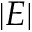Convert formula to latex. <formula><loc_0><loc_0><loc_500><loc_500>| E |</formula> 